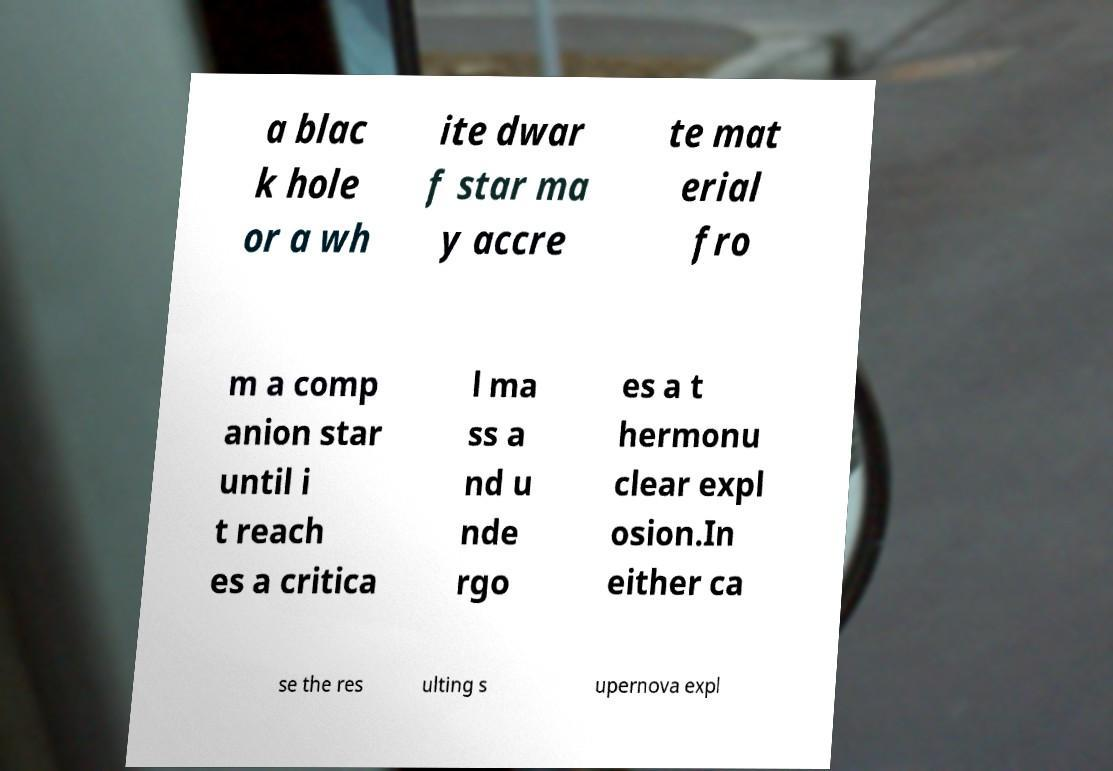I need the written content from this picture converted into text. Can you do that? a blac k hole or a wh ite dwar f star ma y accre te mat erial fro m a comp anion star until i t reach es a critica l ma ss a nd u nde rgo es a t hermonu clear expl osion.In either ca se the res ulting s upernova expl 